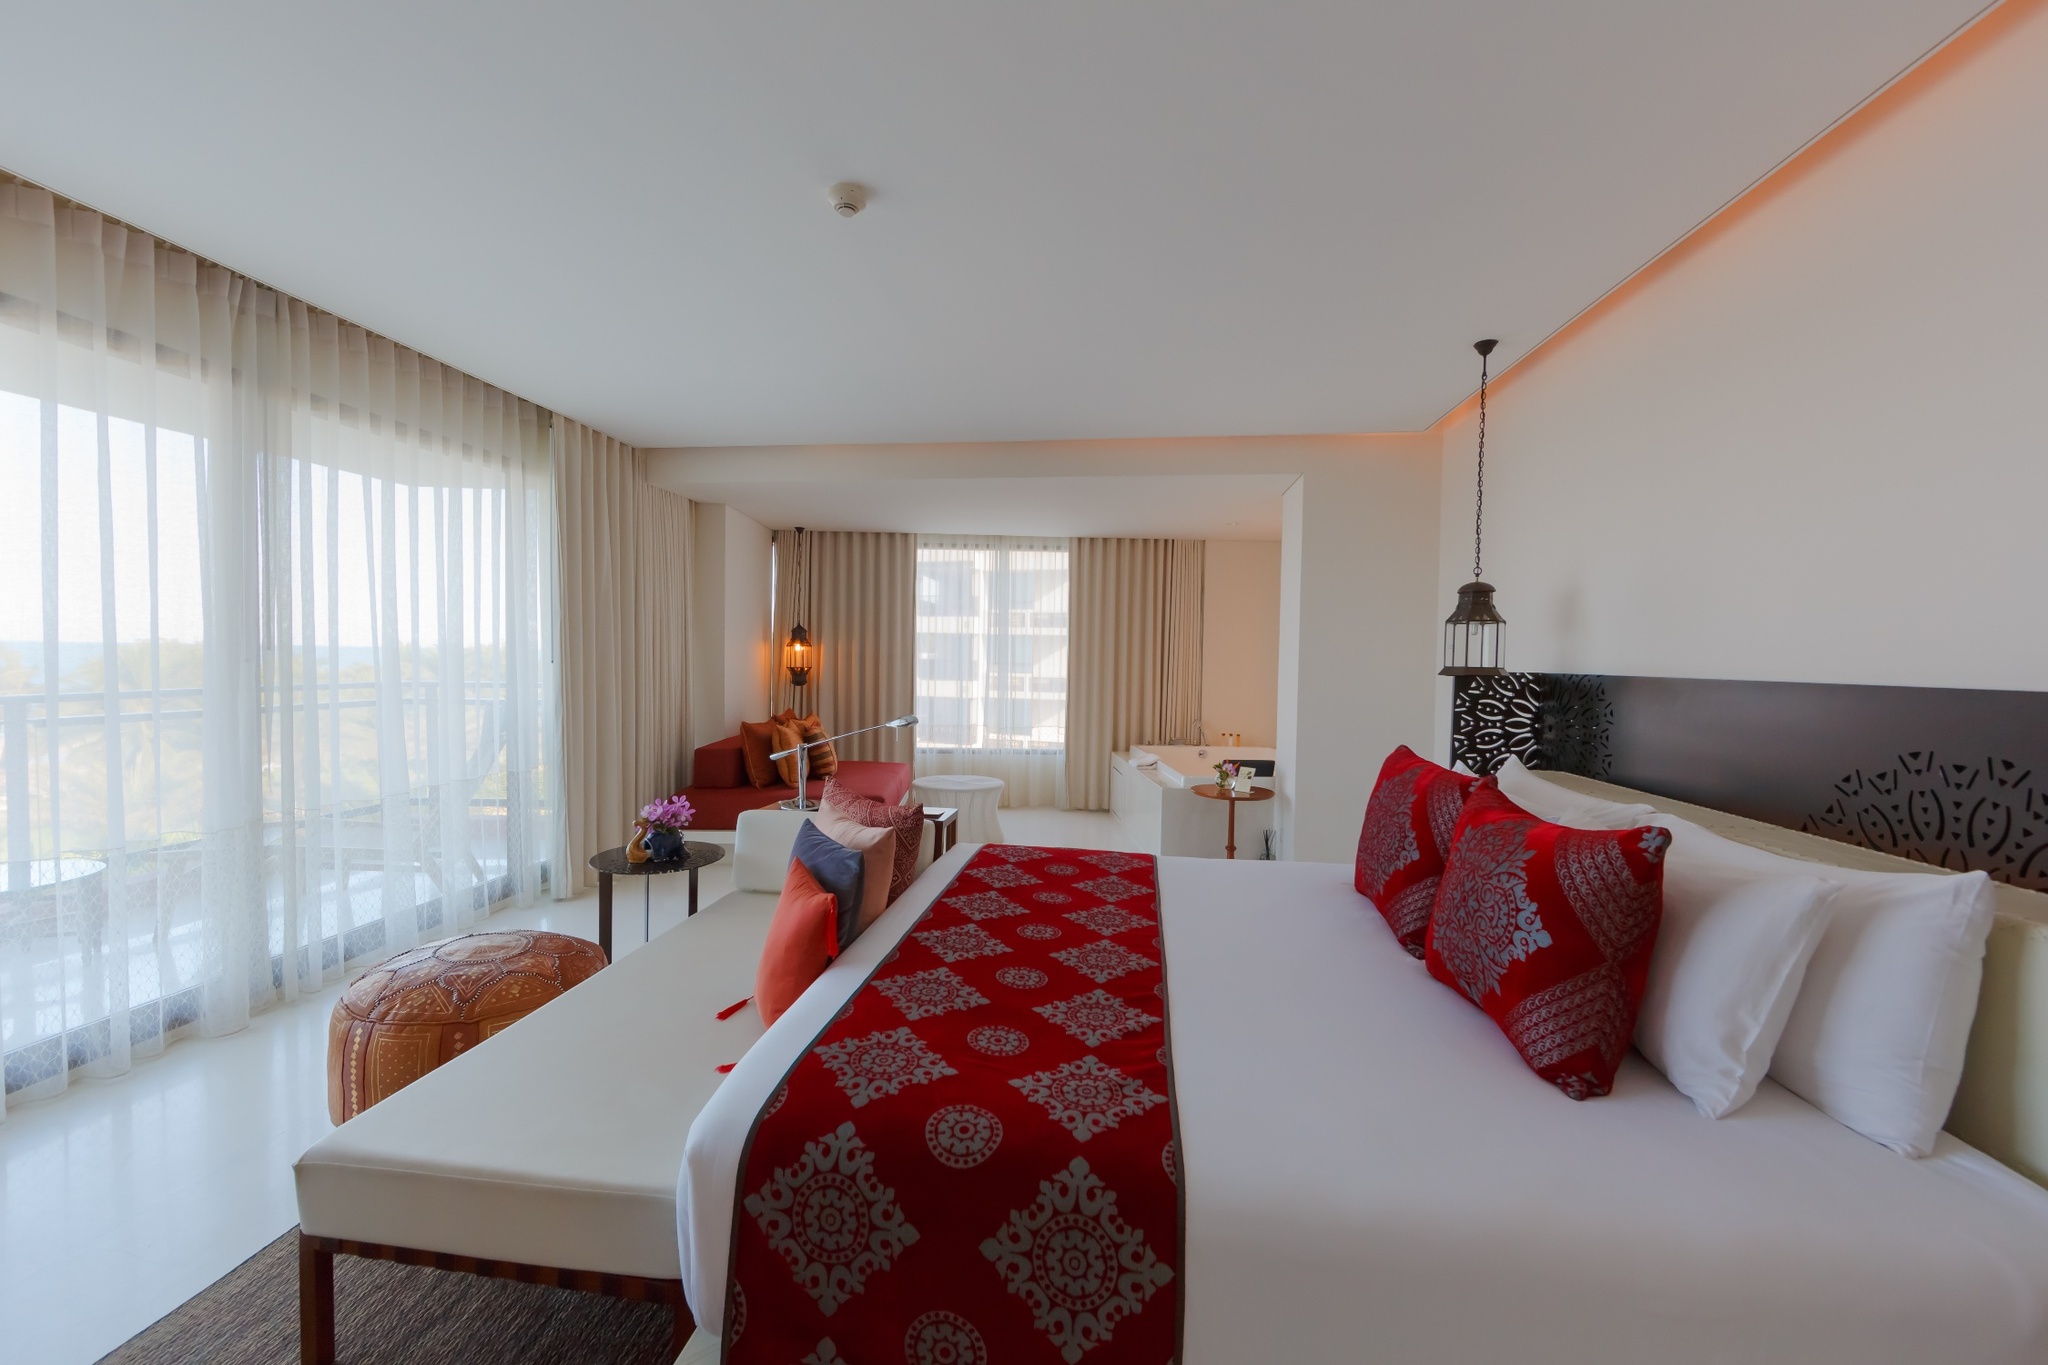Imagine the history behind this hotel. What story does it tell? This hotel room, with its modern elegance and ample space, hints at a rich history of transformation and luxury. Once a historical mansion overlooking vast landscapes, it has been carefully renovated to preserve its classic charm while incorporating contemporary comforts. Over the years, it has hosted notable guests and witnessed countless memorable moments. The intricate decor details, the blend of tradition and modern aesthetics, suggest a place that honors its past while embracing the present. Each room tells a story of heritage, sophistication, and the evolution of luxury hospitality. 